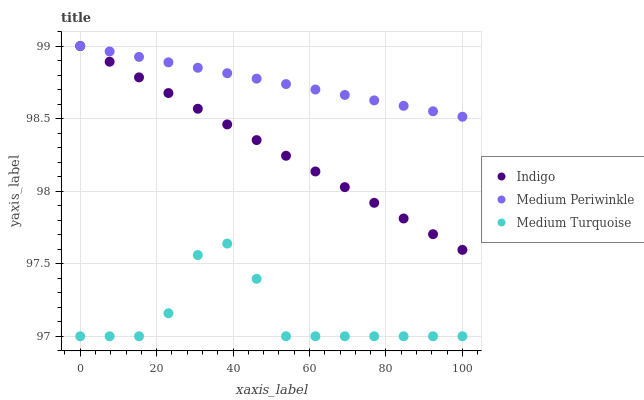Does Medium Turquoise have the minimum area under the curve?
Answer yes or no. Yes. Does Medium Periwinkle have the maximum area under the curve?
Answer yes or no. Yes. Does Indigo have the minimum area under the curve?
Answer yes or no. No. Does Indigo have the maximum area under the curve?
Answer yes or no. No. Is Indigo the smoothest?
Answer yes or no. Yes. Is Medium Turquoise the roughest?
Answer yes or no. Yes. Is Medium Turquoise the smoothest?
Answer yes or no. No. Is Indigo the roughest?
Answer yes or no. No. Does Medium Turquoise have the lowest value?
Answer yes or no. Yes. Does Indigo have the lowest value?
Answer yes or no. No. Does Indigo have the highest value?
Answer yes or no. Yes. Does Medium Turquoise have the highest value?
Answer yes or no. No. Is Medium Turquoise less than Medium Periwinkle?
Answer yes or no. Yes. Is Medium Periwinkle greater than Medium Turquoise?
Answer yes or no. Yes. Does Indigo intersect Medium Periwinkle?
Answer yes or no. Yes. Is Indigo less than Medium Periwinkle?
Answer yes or no. No. Is Indigo greater than Medium Periwinkle?
Answer yes or no. No. Does Medium Turquoise intersect Medium Periwinkle?
Answer yes or no. No. 